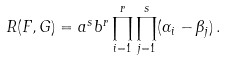<formula> <loc_0><loc_0><loc_500><loc_500>R ( F , G ) = a ^ { s } b ^ { r } \prod _ { i = 1 } ^ { r } \prod _ { j = 1 } ^ { s } ( \alpha _ { i } - \beta _ { j } ) \, .</formula> 